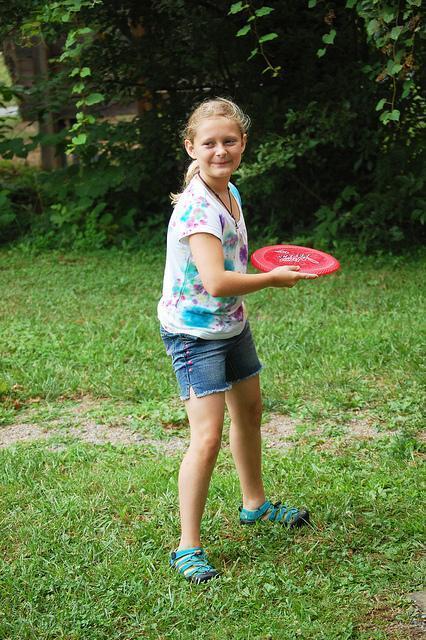How many frisbees are there?
Give a very brief answer. 1. 